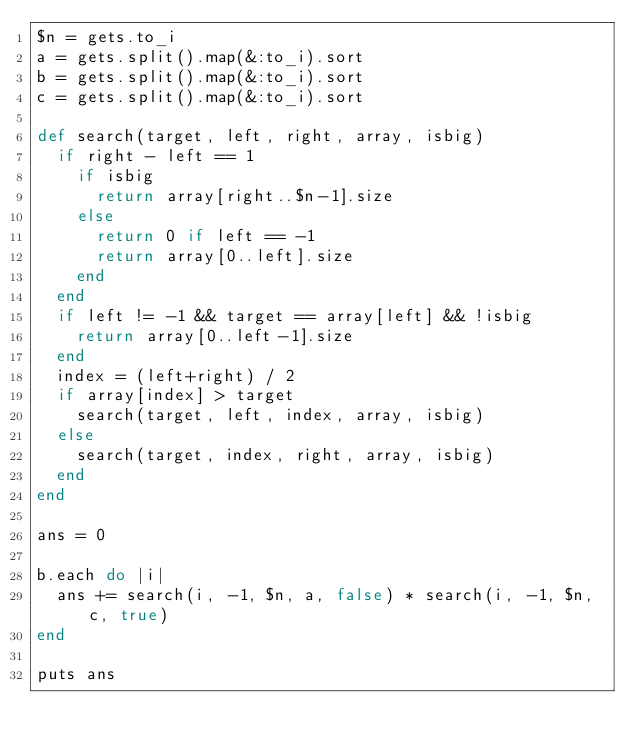<code> <loc_0><loc_0><loc_500><loc_500><_Ruby_>$n = gets.to_i
a = gets.split().map(&:to_i).sort
b = gets.split().map(&:to_i).sort
c = gets.split().map(&:to_i).sort

def search(target, left, right, array, isbig)
  if right - left == 1
    if isbig
      return array[right..$n-1].size
    else
      return 0 if left == -1
      return array[0..left].size
    end
  end
  if left != -1 && target == array[left] && !isbig
    return array[0..left-1].size
  end
  index = (left+right) / 2
  if array[index] > target
    search(target, left, index, array, isbig)
  else
    search(target, index, right, array, isbig)
  end
end

ans = 0

b.each do |i|
  ans += search(i, -1, $n, a, false) * search(i, -1, $n, c, true)
end

puts ans</code> 